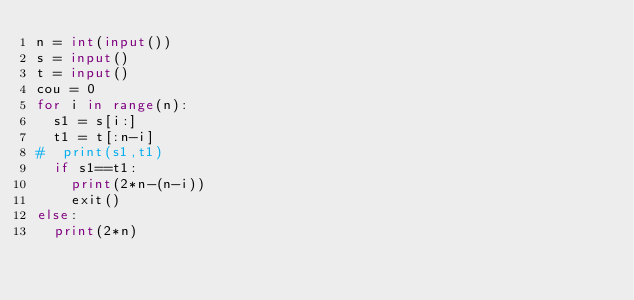<code> <loc_0><loc_0><loc_500><loc_500><_Python_>n = int(input())
s = input()
t = input()
cou = 0
for i in range(n):
  s1 = s[i:]
  t1 = t[:n-i]
#  print(s1,t1)
  if s1==t1:
    print(2*n-(n-i))
    exit()
else:
  print(2*n)
</code> 